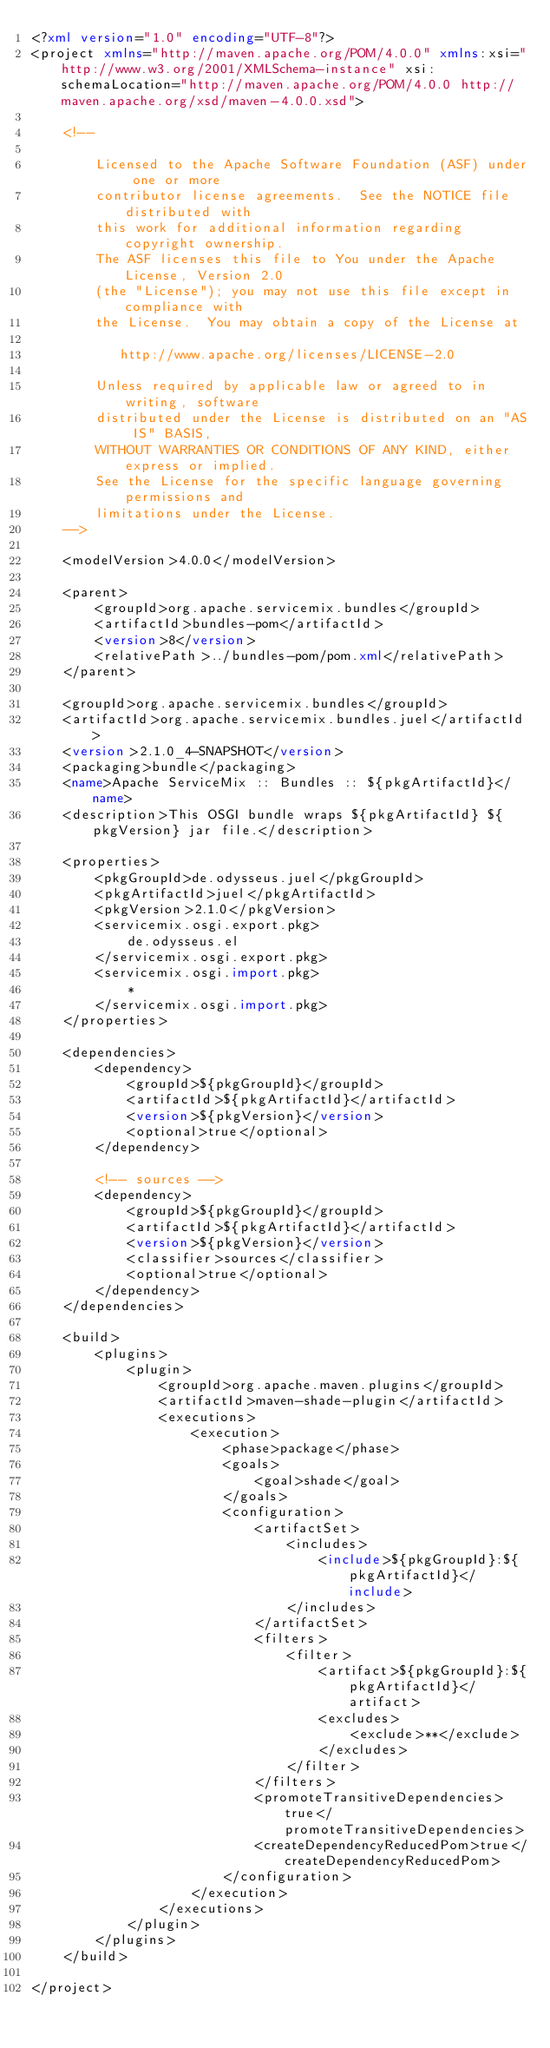Convert code to text. <code><loc_0><loc_0><loc_500><loc_500><_XML_><?xml version="1.0" encoding="UTF-8"?>
<project xmlns="http://maven.apache.org/POM/4.0.0" xmlns:xsi="http://www.w3.org/2001/XMLSchema-instance" xsi:schemaLocation="http://maven.apache.org/POM/4.0.0 http://maven.apache.org/xsd/maven-4.0.0.xsd">

    <!--

        Licensed to the Apache Software Foundation (ASF) under one or more
        contributor license agreements.  See the NOTICE file distributed with
        this work for additional information regarding copyright ownership.
        The ASF licenses this file to You under the Apache License, Version 2.0
        (the "License"); you may not use this file except in compliance with
        the License.  You may obtain a copy of the License at

           http://www.apache.org/licenses/LICENSE-2.0

        Unless required by applicable law or agreed to in writing, software
        distributed under the License is distributed on an "AS IS" BASIS,
        WITHOUT WARRANTIES OR CONDITIONS OF ANY KIND, either express or implied.
        See the License for the specific language governing permissions and
        limitations under the License.
    -->

    <modelVersion>4.0.0</modelVersion>

    <parent>
        <groupId>org.apache.servicemix.bundles</groupId>
        <artifactId>bundles-pom</artifactId>
        <version>8</version>
        <relativePath>../bundles-pom/pom.xml</relativePath>
    </parent>

    <groupId>org.apache.servicemix.bundles</groupId>
    <artifactId>org.apache.servicemix.bundles.juel</artifactId>
    <version>2.1.0_4-SNAPSHOT</version>
    <packaging>bundle</packaging>
    <name>Apache ServiceMix :: Bundles :: ${pkgArtifactId}</name>
    <description>This OSGI bundle wraps ${pkgArtifactId} ${pkgVersion} jar file.</description>

    <properties>
        <pkgGroupId>de.odysseus.juel</pkgGroupId>
        <pkgArtifactId>juel</pkgArtifactId>
        <pkgVersion>2.1.0</pkgVersion>
        <servicemix.osgi.export.pkg>
            de.odysseus.el
        </servicemix.osgi.export.pkg>
        <servicemix.osgi.import.pkg>
            *
        </servicemix.osgi.import.pkg>
    </properties>

    <dependencies>
        <dependency>
            <groupId>${pkgGroupId}</groupId>
            <artifactId>${pkgArtifactId}</artifactId>
            <version>${pkgVersion}</version>
            <optional>true</optional>
        </dependency>

        <!-- sources -->
        <dependency>
            <groupId>${pkgGroupId}</groupId>
            <artifactId>${pkgArtifactId}</artifactId>
            <version>${pkgVersion}</version>
            <classifier>sources</classifier>
            <optional>true</optional>
        </dependency>
    </dependencies>

    <build>
        <plugins>
            <plugin>
                <groupId>org.apache.maven.plugins</groupId>
                <artifactId>maven-shade-plugin</artifactId>
                <executions>
                    <execution>
                        <phase>package</phase>
                        <goals>
                            <goal>shade</goal>
                        </goals>
                        <configuration>
                            <artifactSet>
                                <includes>
                                    <include>${pkgGroupId}:${pkgArtifactId}</include>
                                </includes>
                            </artifactSet>
                            <filters>
                                <filter>
                                    <artifact>${pkgGroupId}:${pkgArtifactId}</artifact>
                                    <excludes>
                                        <exclude>**</exclude>
                                    </excludes>
                                </filter>
                            </filters>
                            <promoteTransitiveDependencies>true</promoteTransitiveDependencies>
                            <createDependencyReducedPom>true</createDependencyReducedPom>
                        </configuration>
                    </execution>
                </executions>
            </plugin>
        </plugins>
    </build>

</project>
</code> 